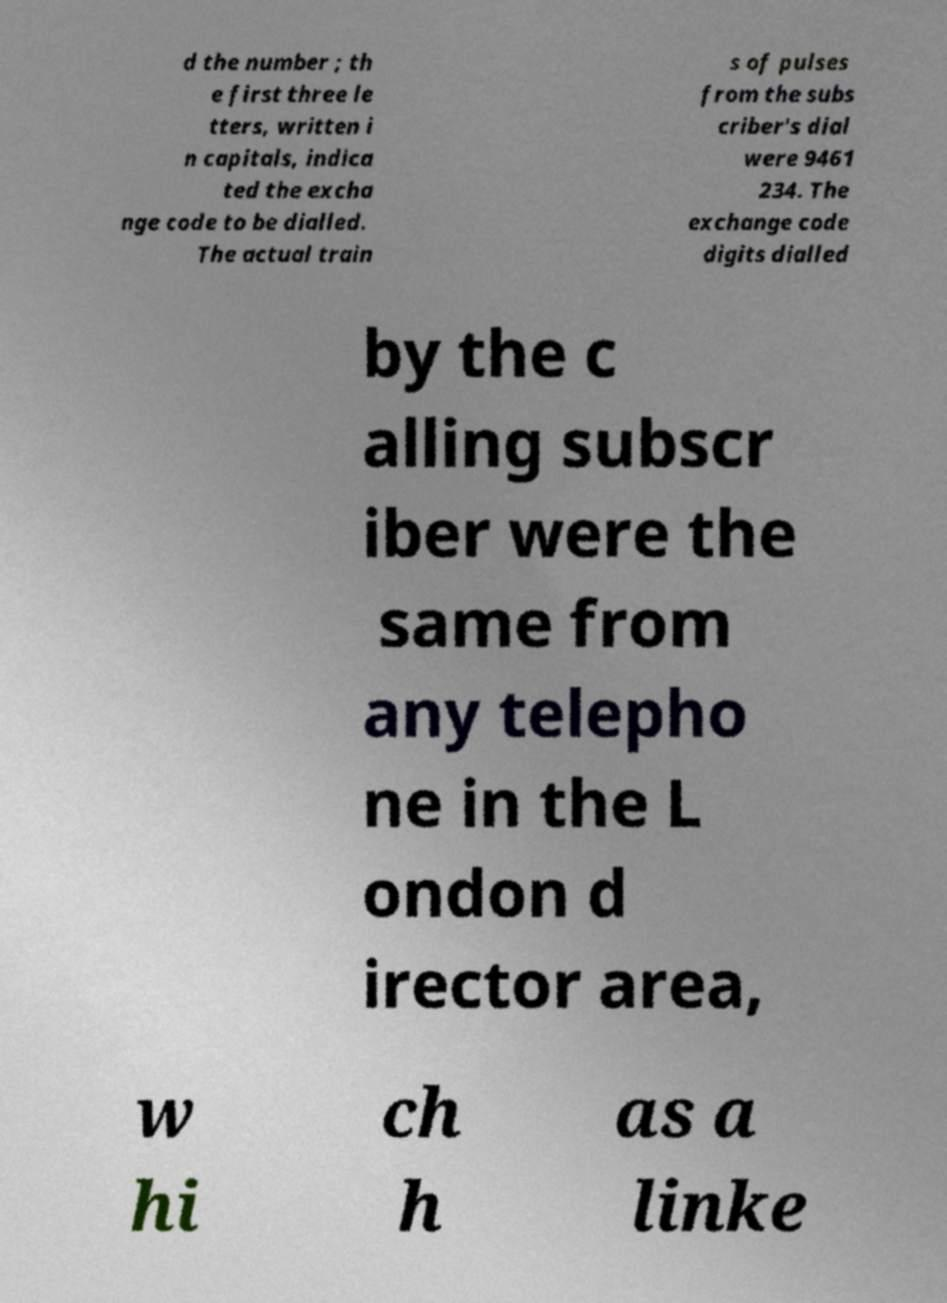I need the written content from this picture converted into text. Can you do that? d the number ; th e first three le tters, written i n capitals, indica ted the excha nge code to be dialled. The actual train s of pulses from the subs criber's dial were 9461 234. The exchange code digits dialled by the c alling subscr iber were the same from any telepho ne in the L ondon d irector area, w hi ch h as a linke 